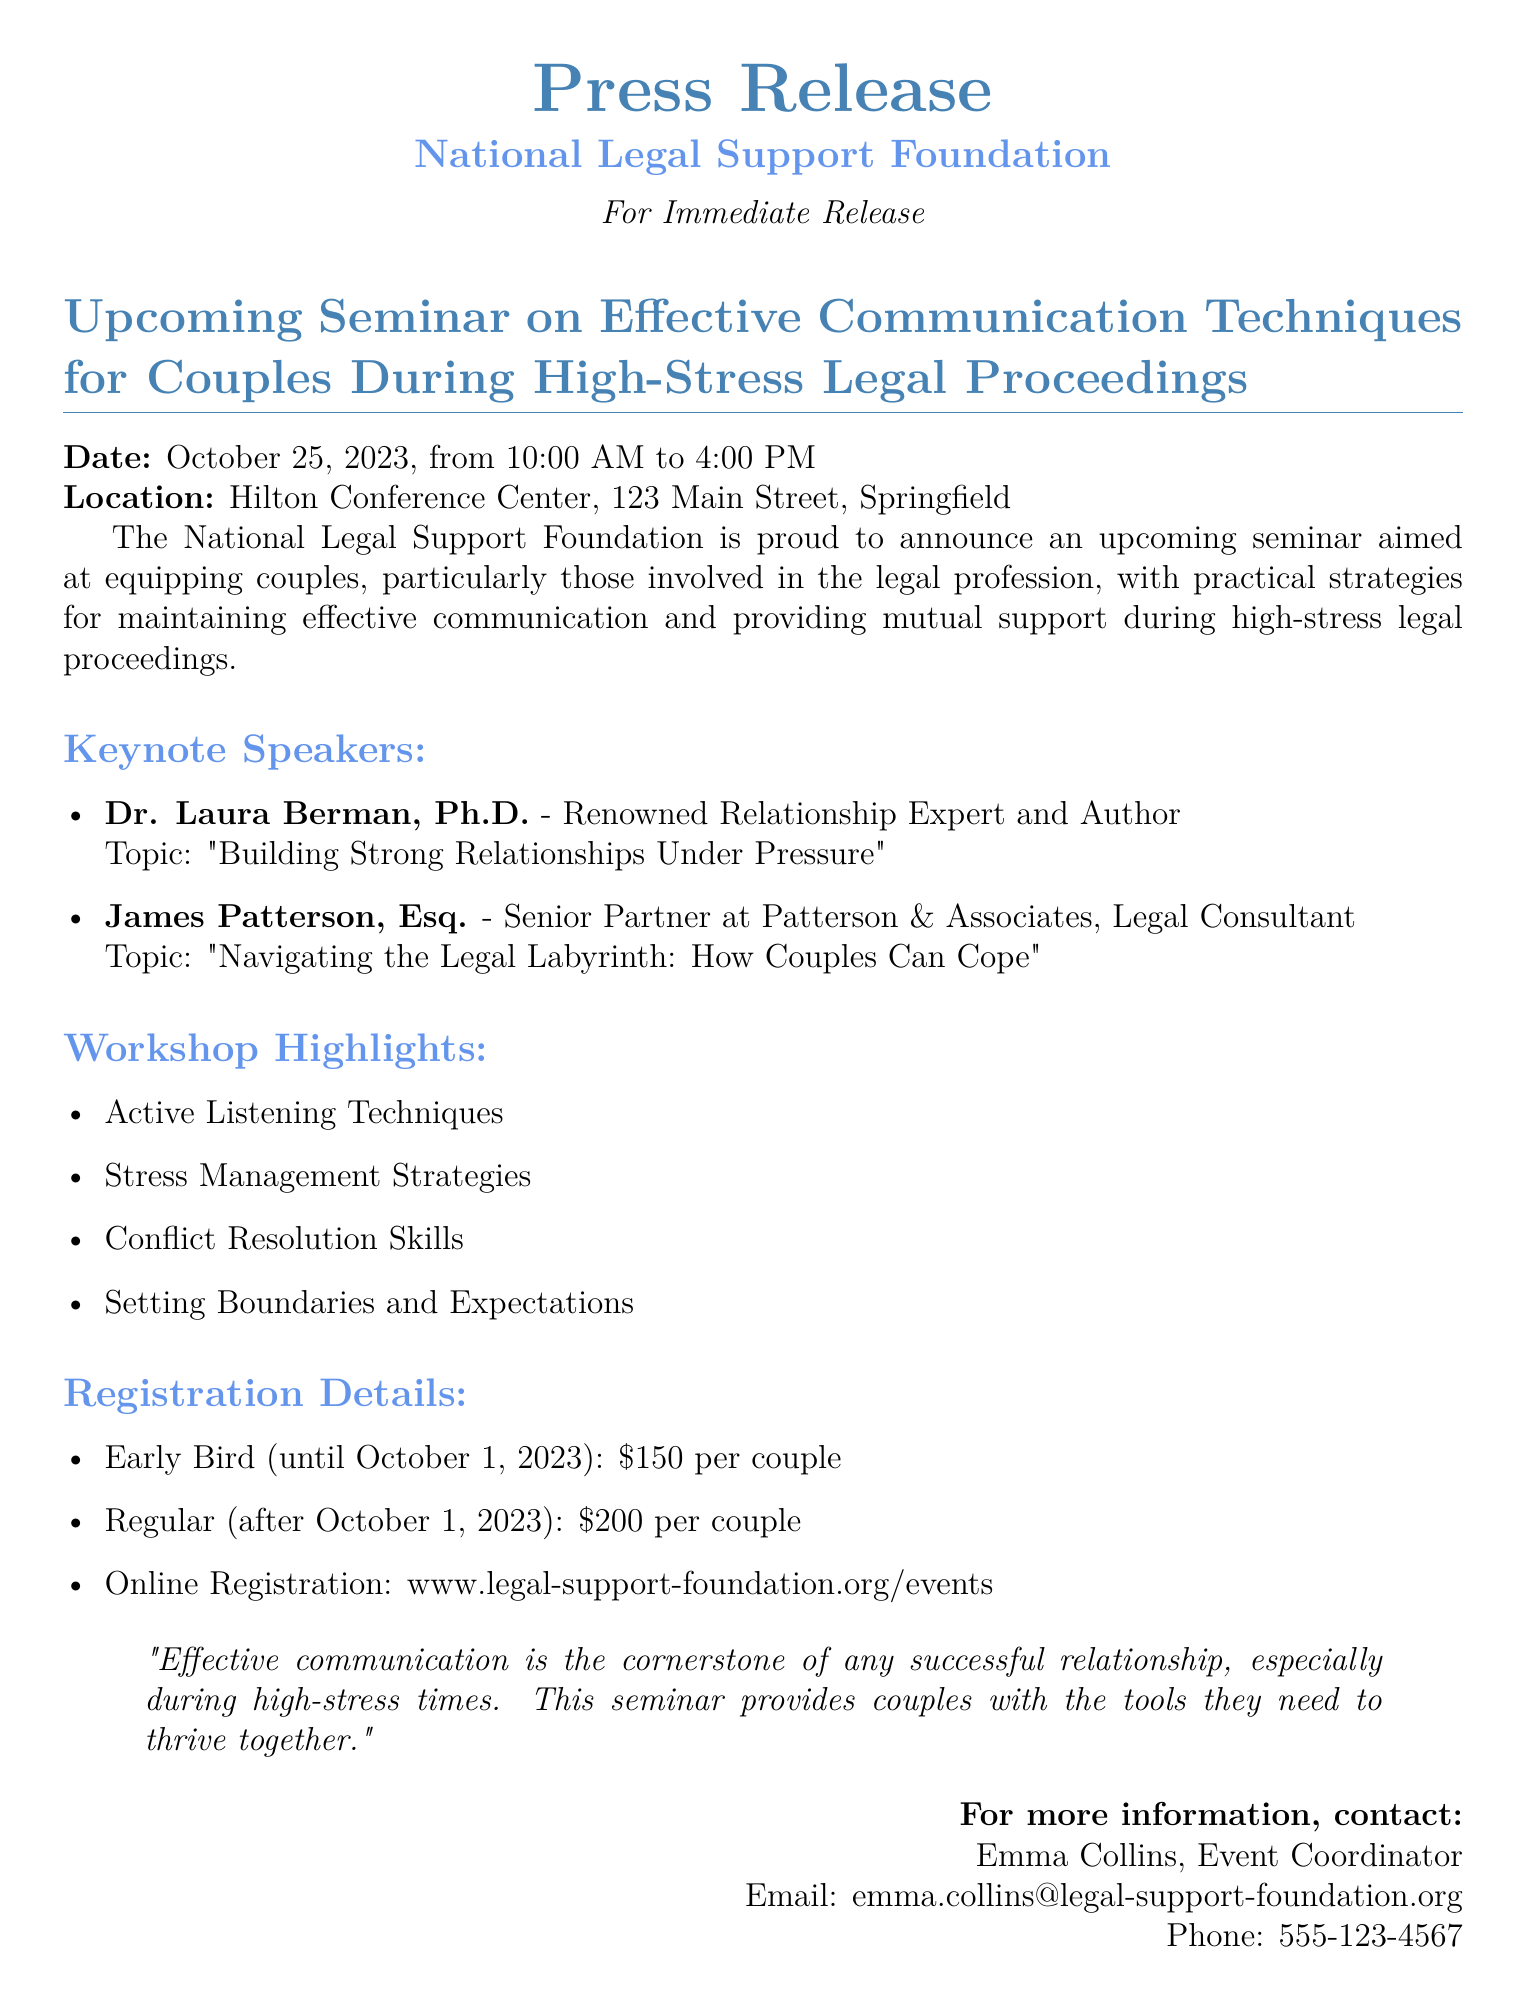What is the date of the seminar? The date of the seminar is mentioned clearly at the top of the document.
Answer: October 25, 2023 Where is the seminar located? The location of the seminar is provided in the document, specifying the venue and address.
Answer: Hilton Conference Center, 123 Main Street, Springfield Who is one of the keynote speakers? The document lists keynote speakers, highlighting Dr. Laura Berman as one.
Answer: Dr. Laura Berman, Ph.D What is the early bird registration fee? The early bird fee is specified in the registration details section of the document.
Answer: $150 per couple What is the total duration of the seminar? The starting and ending times of the seminar are stated, allowing for calculation of the duration.
Answer: 6 hours What topic will James Patterson discuss? The topic assigned to James Patterson is presented in the document under his name.
Answer: Navigating the Legal Labyrinth: How Couples Can Cope What type of strategies will be discussed in the workshop? The document highlights that the workshop will cover various techniques related to communication and stress.
Answer: Active Listening Techniques What is the primary focus of the seminar? The first part of the document outlines the seminar's aim concerning couples during legal proceedings.
Answer: Effective communication techniques for couples during high-stress legal proceedings Who to contact for more information? The contact information section provides a name for inquiries regarding the seminar.
Answer: Emma Collins, Event Coordinator 